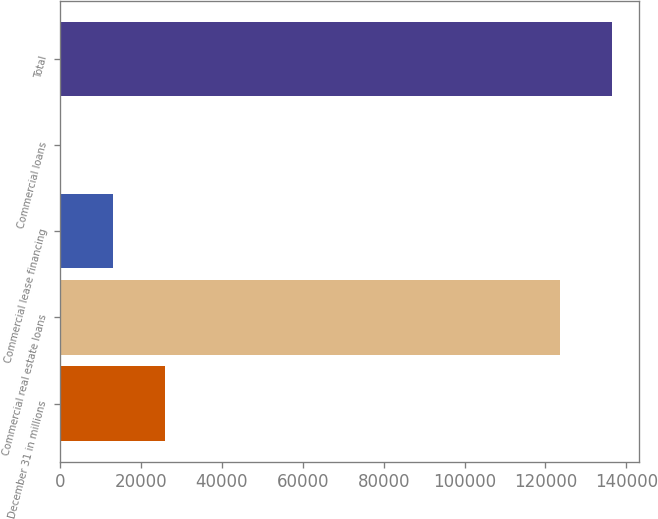Convert chart. <chart><loc_0><loc_0><loc_500><loc_500><bar_chart><fcel>December 31 in millions<fcel>Commercial real estate loans<fcel>Commercial lease financing<fcel>Commercial loans<fcel>Total<nl><fcel>25858.6<fcel>123599<fcel>13052.8<fcel>247<fcel>136405<nl></chart> 